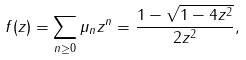<formula> <loc_0><loc_0><loc_500><loc_500>f ( z ) = \sum _ { n \geq 0 } \mu _ { n } z ^ { n } = \frac { 1 - \sqrt { 1 - 4 z ^ { 2 } } } { 2 z ^ { 2 } } ,</formula> 